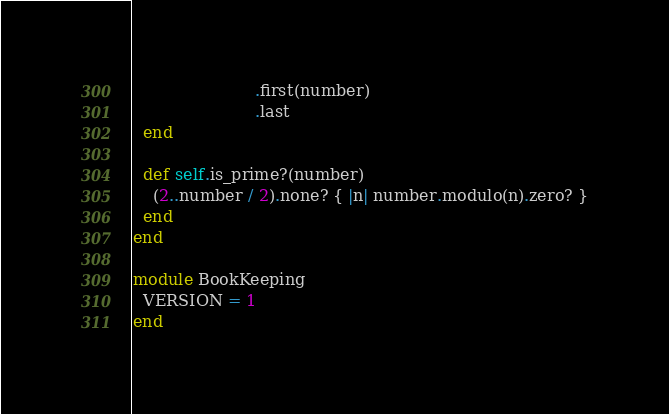Convert code to text. <code><loc_0><loc_0><loc_500><loc_500><_Ruby_>                        .first(number)
                        .last
  end

  def self.is_prime?(number)
    (2..number / 2).none? { |n| number.modulo(n).zero? }
  end
end

module BookKeeping
  VERSION = 1
end</code> 